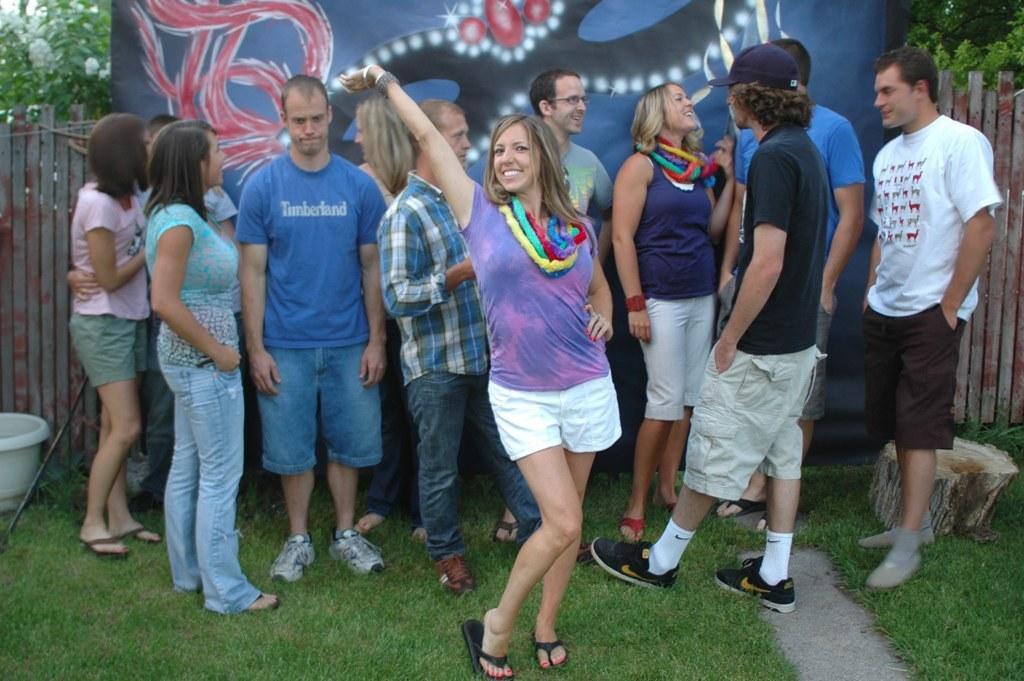Can you describe this image briefly? In the picture I can see a group of people are standing on the ground. In the background I can see a banner, wooden fence, the grass, trees and some other objects. 